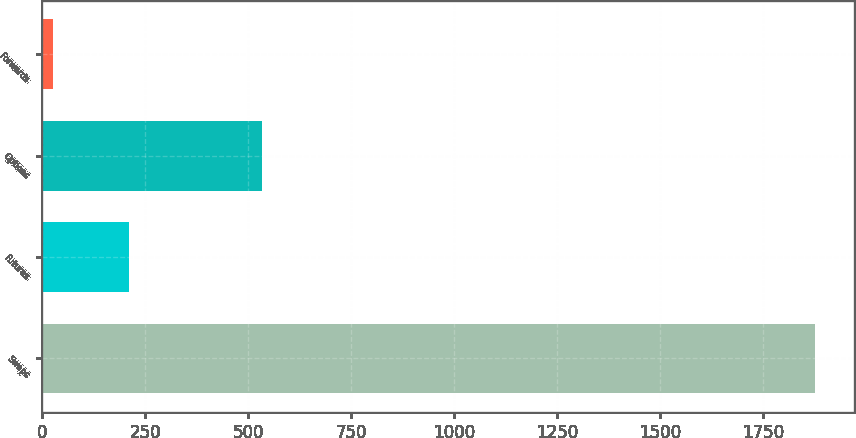Convert chart. <chart><loc_0><loc_0><loc_500><loc_500><bar_chart><fcel>Swaps<fcel>Futures<fcel>Options<fcel>Forwards<nl><fcel>1876<fcel>211<fcel>534<fcel>26<nl></chart> 